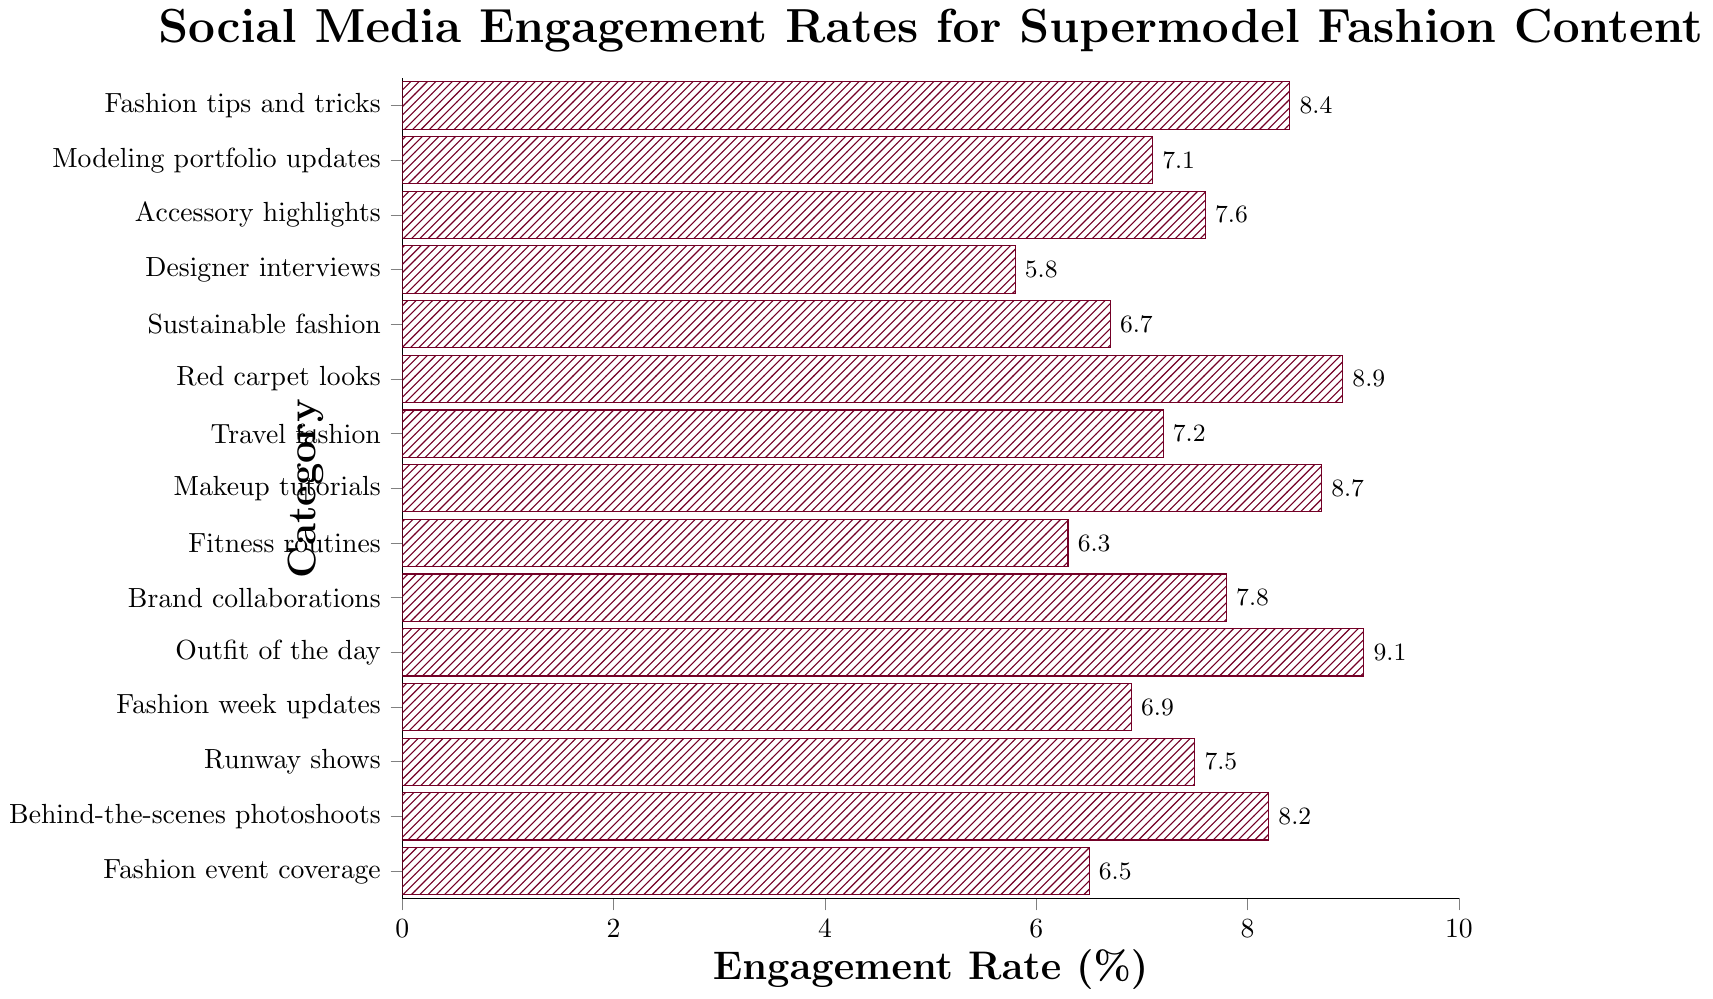Which category has the highest engagement rate? Identify the bar with the highest length on the x-axis, which represents the engagement rate in the figure.
Answer: Outfit of the day Which category has a higher engagement rate: "Runway shows" or "Brand collaborations"? Examine the length of the bars corresponding to "Runway shows" and "Brand collaborations". "Brand collaborations" has a longer bar.
Answer: Brand collaborations What is the combined engagement rate for "Red carpet looks" and "Makeup tutorials"? Add the engagement rates of "Red carpet looks" (8.9) and "Makeup tutorials" (8.7). So, 8.9 + 8.7 = 17.6.
Answer: 17.6 Which category has the lowest engagement rate? Locate the shortest bar on the x-axis. "Designer interviews" has the shortest bar.
Answer: Designer interviews Are there any categories with an engagement rate equal to or above 9%? Identify bars that extend to or beyond the 9% mark. "Outfit of the day" is at 9.1%, so it's equal to or above 9%.
Answer: Yes What is the difference in engagement rates between "Behind-the-scenes photoshoots" and "Fashion week updates"? Subtract the engagement rate of "Fashion week updates" (6.9) from "Behind-the-scenes photoshoots" (8.2). So, 8.2 - 6.9 = 1.3.
Answer: 1.3 Which categories fall below the engagement rate of 6%? Find bars that are shorter than the 6% mark. "Designer interviews" falls in this range.
Answer: Designer interviews How many categories have an engagement rate between 7% and 8%? Count the bars with lengths between the 7% and 8% marks. There are five such categories: "Runway shows", "Brand collaborations", "Accessory highlights", "Travel fashion", and "Modeling portfolio updates".
Answer: 5 Are there more categories with an engagement rate above 7% or below 7%? Count the number of bars above and below the 7% mark. Above 7%: 10 categories. Below 7%: 5 categories. Therefore, more categories have an engagement rate above 7%.
Answer: Above 7% What is the average engagement rate of "Fashion event coverage", "Fitness routines", and "Sustainable fashion"? Add the engagement rates of the three categories and divide by 3. (6.5 + 6.3 + 6.7) / 3 = 19.5 / 3 = 6.5.
Answer: 6.5 